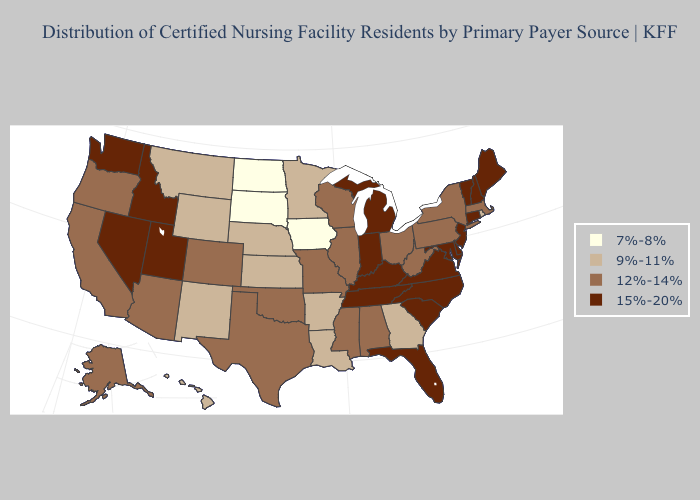What is the lowest value in the West?
Short answer required. 9%-11%. What is the lowest value in states that border Illinois?
Be succinct. 7%-8%. Name the states that have a value in the range 12%-14%?
Quick response, please. Alabama, Alaska, Arizona, California, Colorado, Illinois, Massachusetts, Mississippi, Missouri, New York, Ohio, Oklahoma, Oregon, Pennsylvania, Texas, West Virginia, Wisconsin. Which states have the lowest value in the USA?
Answer briefly. Iowa, North Dakota, South Dakota. Does Florida have the highest value in the USA?
Keep it brief. Yes. What is the highest value in the USA?
Keep it brief. 15%-20%. What is the value of Washington?
Quick response, please. 15%-20%. Name the states that have a value in the range 7%-8%?
Quick response, please. Iowa, North Dakota, South Dakota. Which states have the lowest value in the South?
Be succinct. Arkansas, Georgia, Louisiana. What is the lowest value in states that border Louisiana?
Keep it brief. 9%-11%. Among the states that border Rhode Island , does Massachusetts have the lowest value?
Short answer required. Yes. Does Maine have a higher value than Illinois?
Keep it brief. Yes. Is the legend a continuous bar?
Concise answer only. No. Does New Hampshire have the same value as Michigan?
Answer briefly. Yes. Does New York have a higher value than Montana?
Short answer required. Yes. 